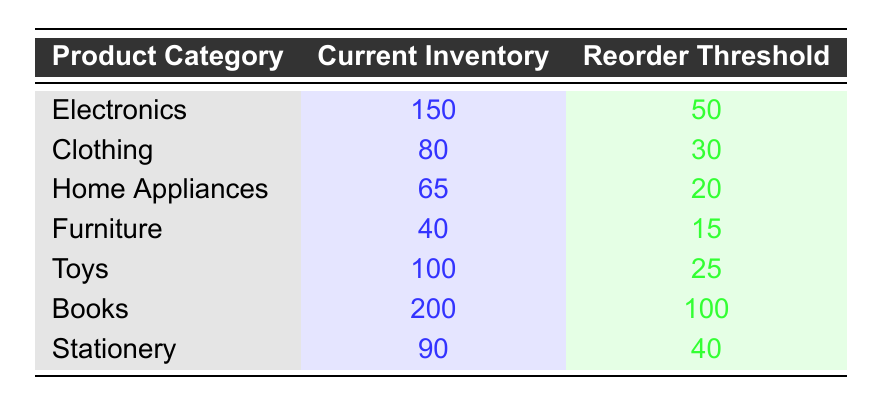What is the current inventory level for Home Appliances? The table directly displays the current inventory level for Home Appliances, which is listed in the corresponding row.
Answer: 65 Which product category has the highest reorder threshold? By reviewing the reorder thresholds listed for all product categories, "Books" has the highest value of 100.
Answer: Books What is the total current inventory for Clothing and Furniture combined? To find the total, add the current inventory of Clothing (80) and Furniture (40): 80 + 40 = 120.
Answer: 120 Is the current inventory of Electronics above its reorder threshold? The current inventory for Electronics is 150, and the reorder threshold is 50. Since 150 is greater than 50, the statement is true.
Answer: Yes What is the average current inventory level across all product categories? To calculate the average, sum the current inventories: 150 + 80 + 65 + 40 + 100 + 200 + 90 = 725. Then divide by the number of categories (7): 725 / 7 ≈ 103.57.
Answer: Approximately 103.57 Which product category has the lowest current inventory? By comparing the current inventory levels across all categories, "Furniture" is listed with the lowest inventory at 40.
Answer: Furniture How many product categories have a current inventory below their reorder threshold? Review each category: Furniture (40 < 15), Home Appliances (65 < 20), and Toys (100 < 25). Only Furniture meets this criteria, so there is one category.
Answer: 1 Is the current inventory of Stationery at least double its reorder threshold? The current inventory for Stationery is 90, and its reorder threshold is 40. Since 90 is greater than double 40 (which is 80), the statement is true.
Answer: Yes What is the difference between the current inventory of Books and the current inventory of Home Appliances? To find the difference, subtract the current inventory for Home Appliances (65) from Books (200): 200 - 65 = 135.
Answer: 135 